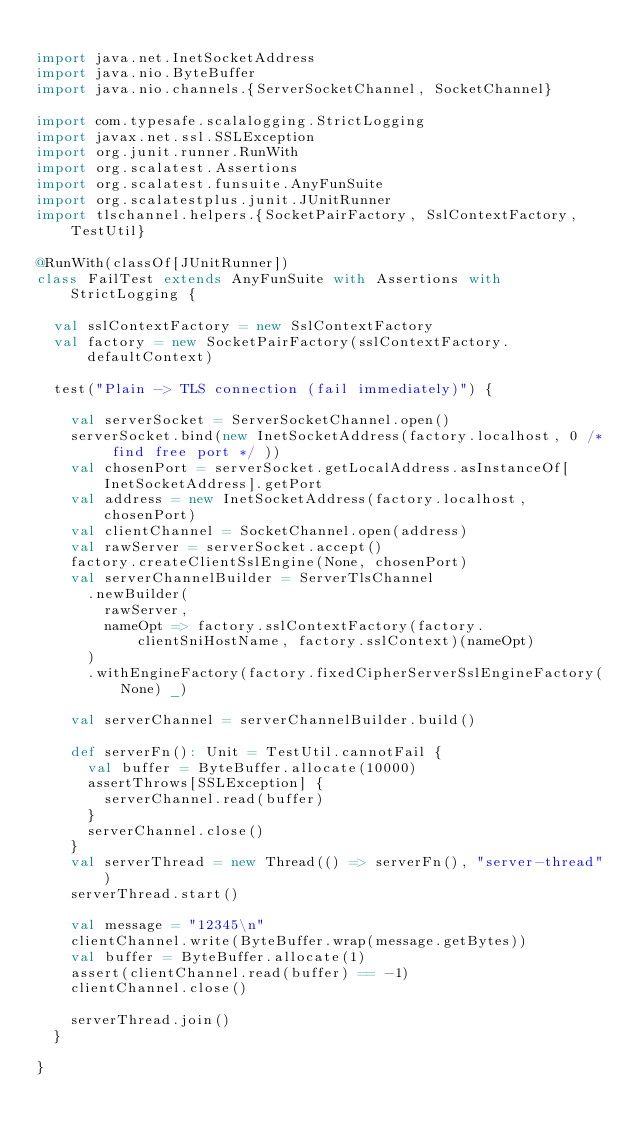<code> <loc_0><loc_0><loc_500><loc_500><_Scala_>
import java.net.InetSocketAddress
import java.nio.ByteBuffer
import java.nio.channels.{ServerSocketChannel, SocketChannel}

import com.typesafe.scalalogging.StrictLogging
import javax.net.ssl.SSLException
import org.junit.runner.RunWith
import org.scalatest.Assertions
import org.scalatest.funsuite.AnyFunSuite
import org.scalatestplus.junit.JUnitRunner
import tlschannel.helpers.{SocketPairFactory, SslContextFactory, TestUtil}

@RunWith(classOf[JUnitRunner])
class FailTest extends AnyFunSuite with Assertions with StrictLogging {

  val sslContextFactory = new SslContextFactory
  val factory = new SocketPairFactory(sslContextFactory.defaultContext)

  test("Plain -> TLS connection (fail immediately)") {

    val serverSocket = ServerSocketChannel.open()
    serverSocket.bind(new InetSocketAddress(factory.localhost, 0 /* find free port */ ))
    val chosenPort = serverSocket.getLocalAddress.asInstanceOf[InetSocketAddress].getPort
    val address = new InetSocketAddress(factory.localhost, chosenPort)
    val clientChannel = SocketChannel.open(address)
    val rawServer = serverSocket.accept()
    factory.createClientSslEngine(None, chosenPort)
    val serverChannelBuilder = ServerTlsChannel
      .newBuilder(
        rawServer,
        nameOpt => factory.sslContextFactory(factory.clientSniHostName, factory.sslContext)(nameOpt)
      )
      .withEngineFactory(factory.fixedCipherServerSslEngineFactory(None) _)

    val serverChannel = serverChannelBuilder.build()

    def serverFn(): Unit = TestUtil.cannotFail {
      val buffer = ByteBuffer.allocate(10000)
      assertThrows[SSLException] {
        serverChannel.read(buffer)
      }
      serverChannel.close()
    }
    val serverThread = new Thread(() => serverFn(), "server-thread")
    serverThread.start()

    val message = "12345\n"
    clientChannel.write(ByteBuffer.wrap(message.getBytes))
    val buffer = ByteBuffer.allocate(1)
    assert(clientChannel.read(buffer) == -1)
    clientChannel.close()

    serverThread.join()
  }

}
</code> 